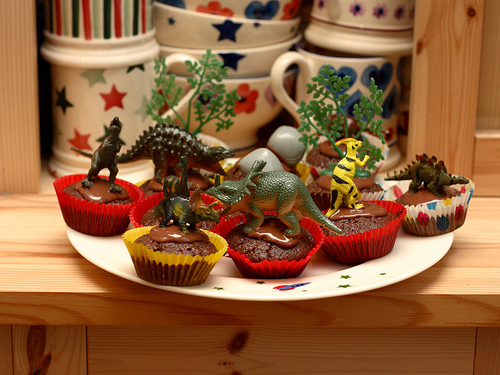<image>
Can you confirm if the cup is above the triceratops? No. The cup is not positioned above the triceratops. The vertical arrangement shows a different relationship. 